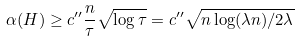Convert formula to latex. <formula><loc_0><loc_0><loc_500><loc_500>\alpha ( H ) \geq c ^ { \prime \prime } \frac { n } { \tau } \sqrt { \log \tau } = c ^ { \prime \prime } \sqrt { n \log ( \lambda n ) / 2 \lambda }</formula> 